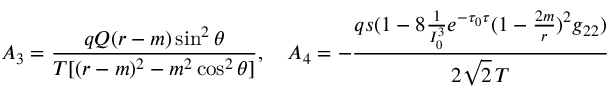<formula> <loc_0><loc_0><loc_500><loc_500>A _ { 3 } = { \frac { q Q ( r - m ) \sin ^ { 2 } \theta } { T [ ( r - m ) ^ { 2 } - m ^ { 2 } \cos ^ { 2 } \theta ] } } , \quad A _ { 4 } = - { \frac { q s ( 1 - 8 { \frac { 1 } { I _ { 0 } ^ { 3 } } } e ^ { - \tau _ { 0 } \tau } ( 1 - { \frac { 2 m } { r } } ) ^ { 2 } g _ { 2 2 } ) } { 2 \sqrt { 2 } \, T } }</formula> 